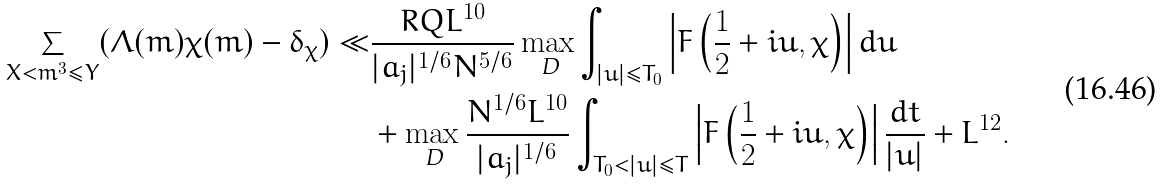<formula> <loc_0><loc_0><loc_500><loc_500>\sum _ { X < m ^ { 3 } \leq Y } ( \Lambda ( m ) \chi ( m ) - \delta _ { \chi } ) \ll & \frac { R Q L ^ { 1 0 } } { | a _ { j } | ^ { 1 / 6 } N ^ { 5 / 6 } } \max _ { \text { D} } \int _ { | u | \leq T _ { 0 } } \left | F \left ( \frac { 1 } { 2 } + i u , \chi \right ) \right | d u \\ & + \max _ { \text { D} } \frac { N ^ { 1 / 6 } L ^ { 1 0 } } { | a _ { j } | ^ { 1 / 6 } } \int _ { T _ { 0 } < | u | \leq T } \left | F \left ( \frac { 1 } { 2 } + i u , \chi \right ) \right | \frac { d t } { | u | } + L ^ { 1 2 } .</formula> 